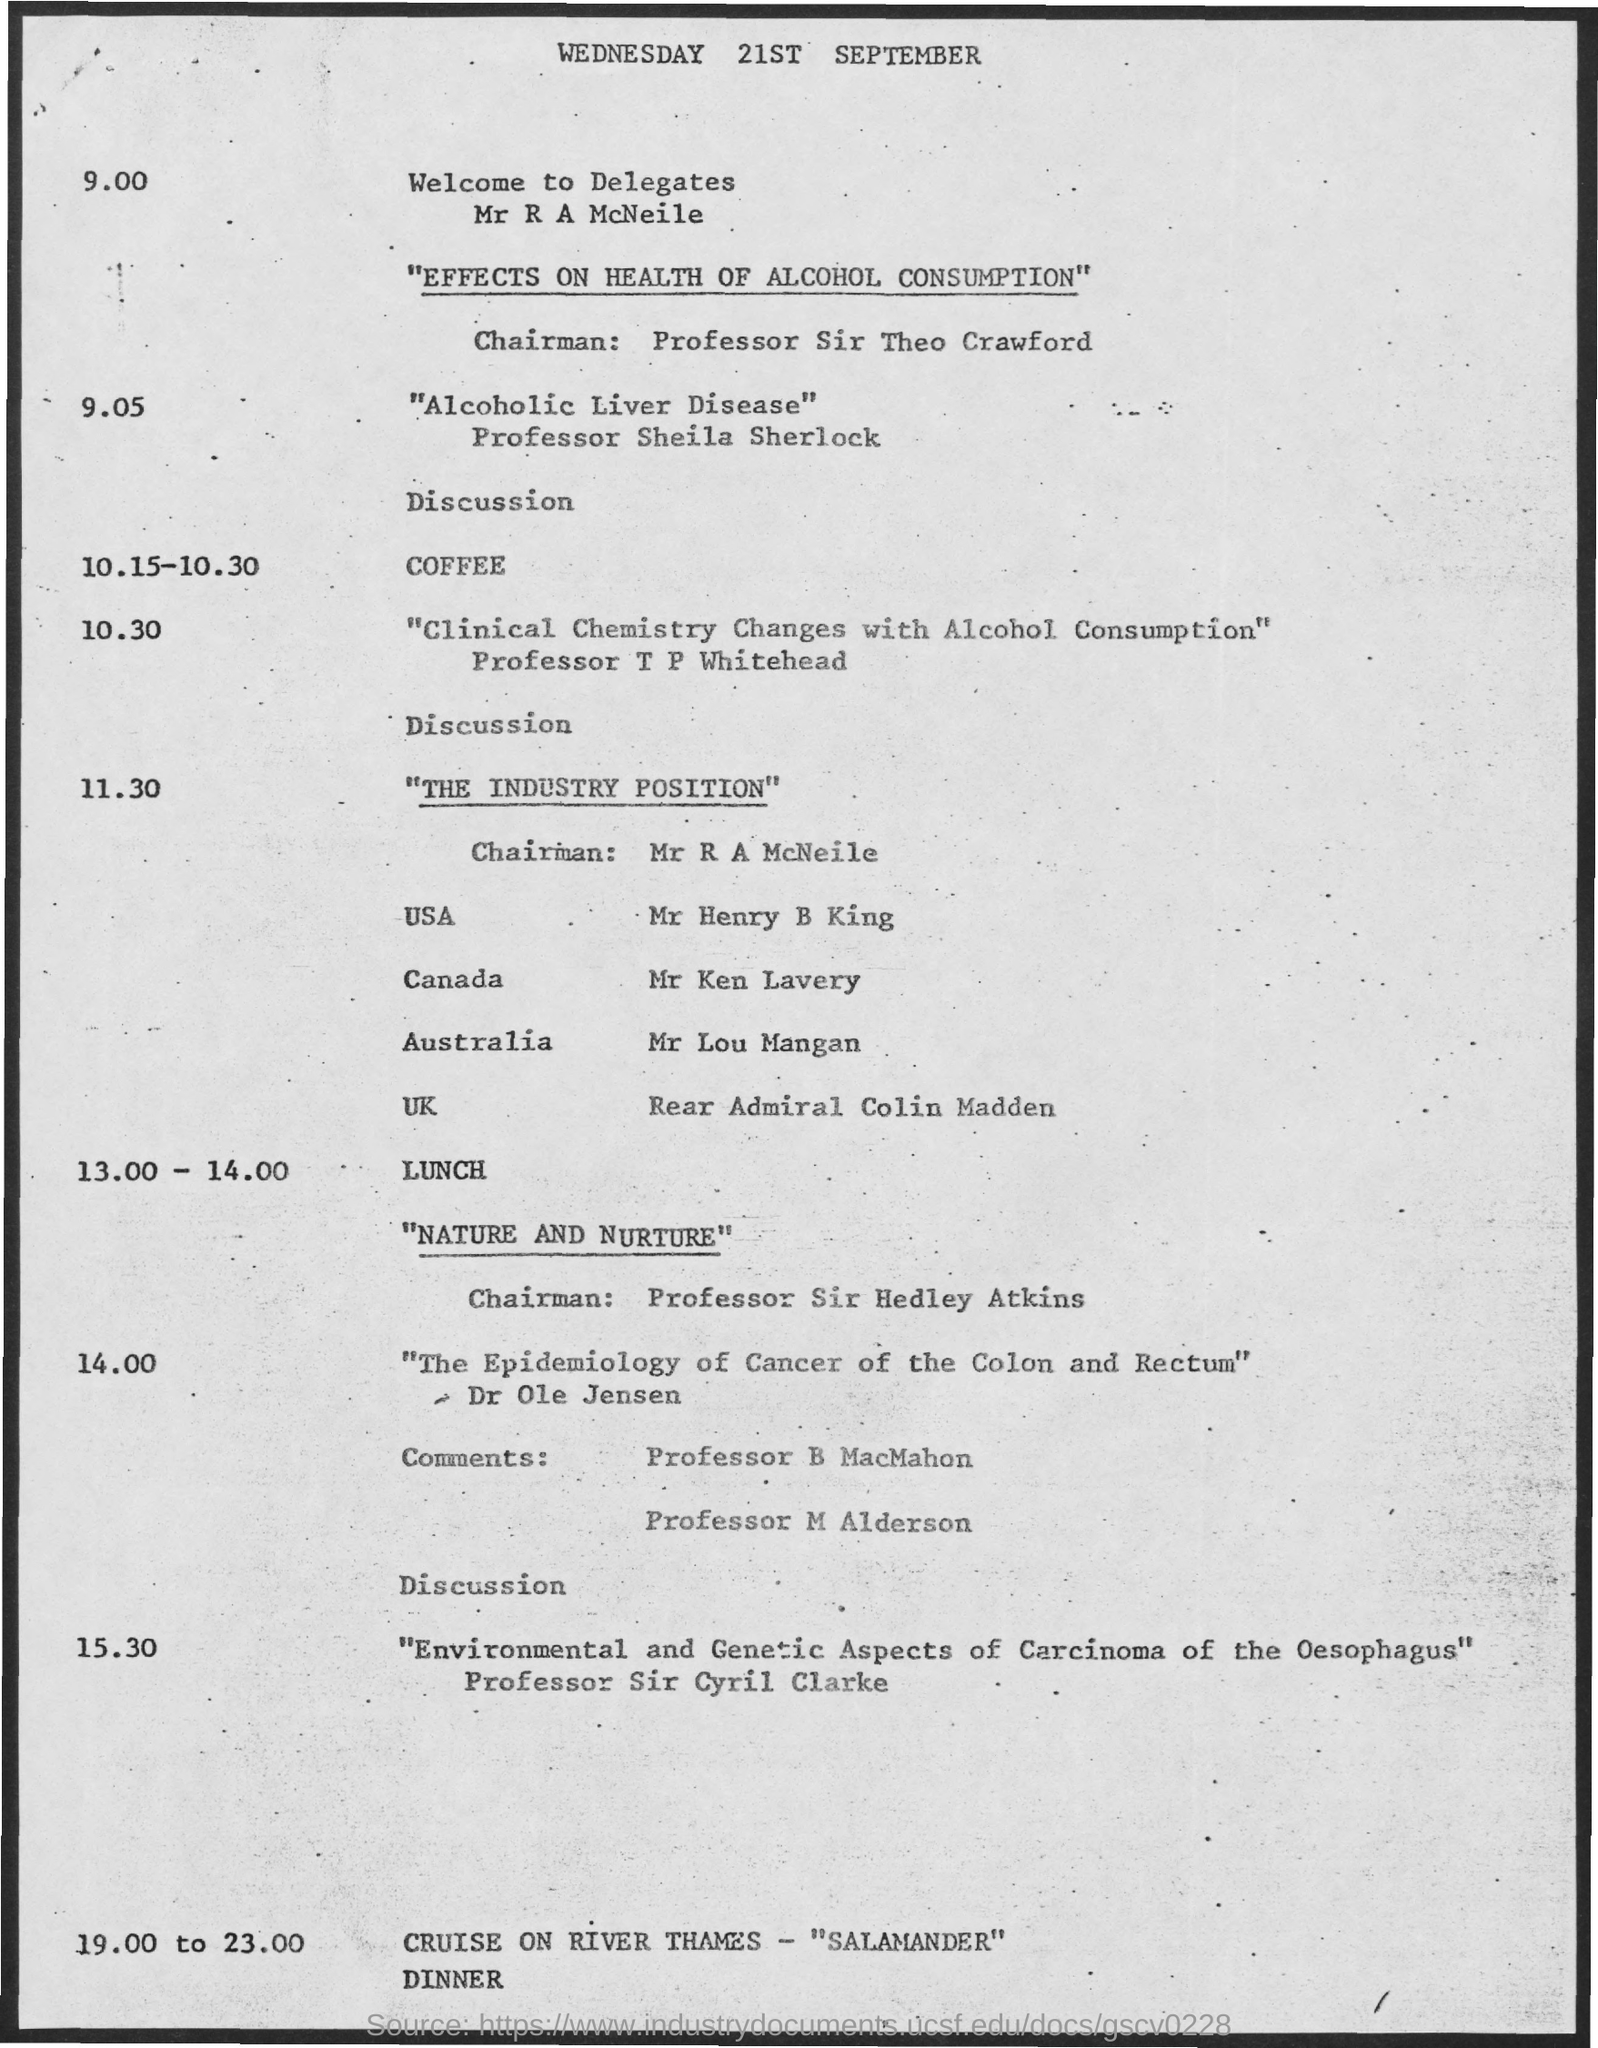Draw attention to some important aspects in this diagram. The document contains the date "Wednesday 21st September.." which is being declared. 